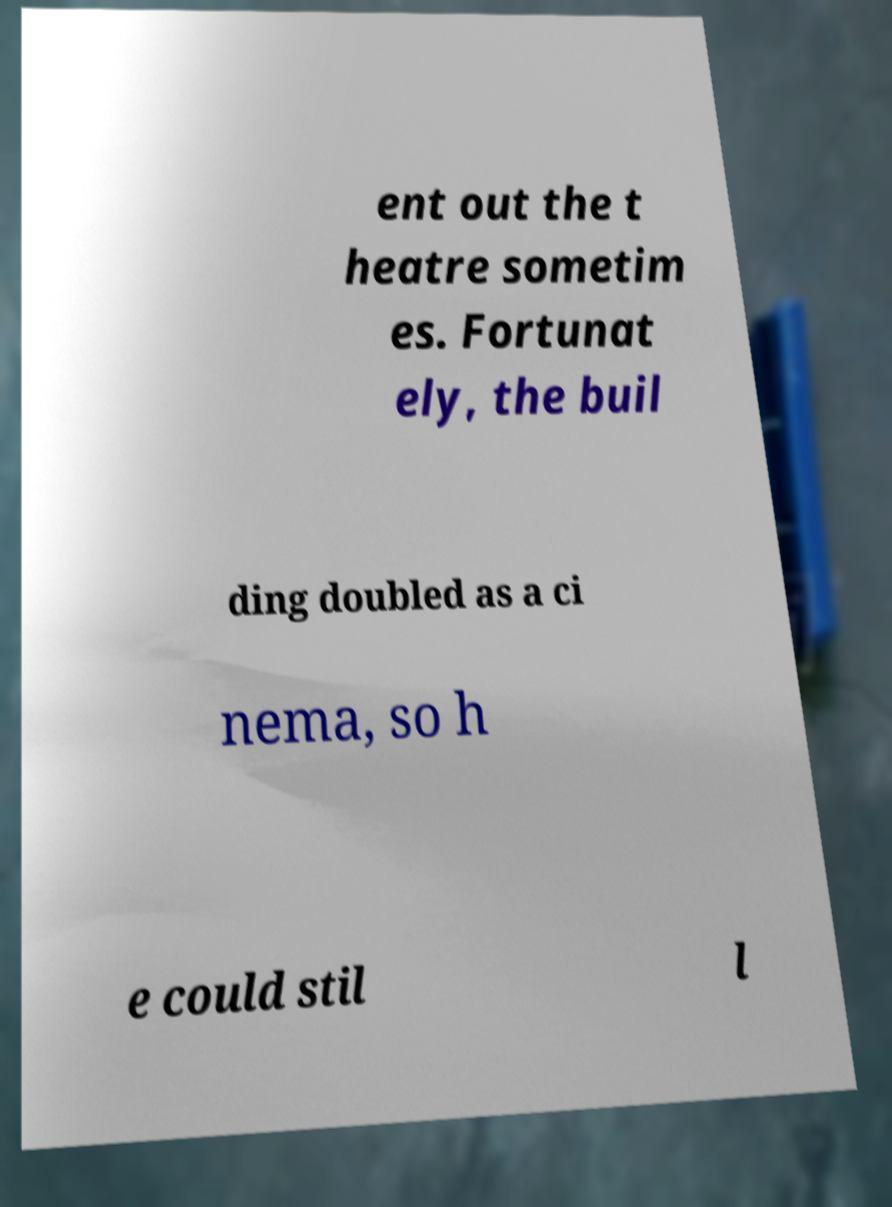Could you extract and type out the text from this image? ent out the t heatre sometim es. Fortunat ely, the buil ding doubled as a ci nema, so h e could stil l 